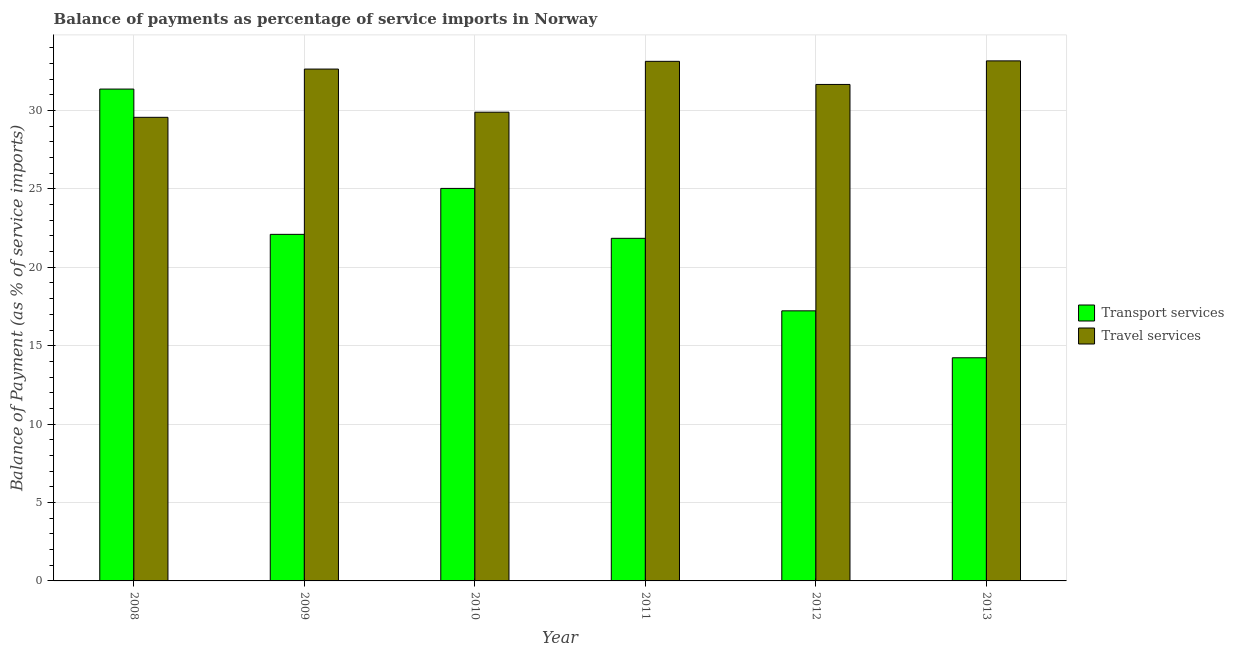Are the number of bars per tick equal to the number of legend labels?
Offer a terse response. Yes. Are the number of bars on each tick of the X-axis equal?
Your response must be concise. Yes. What is the label of the 1st group of bars from the left?
Keep it short and to the point. 2008. What is the balance of payments of travel services in 2012?
Make the answer very short. 31.66. Across all years, what is the maximum balance of payments of travel services?
Provide a short and direct response. 33.16. Across all years, what is the minimum balance of payments of transport services?
Offer a very short reply. 14.23. What is the total balance of payments of travel services in the graph?
Your response must be concise. 190.05. What is the difference between the balance of payments of transport services in 2011 and that in 2013?
Provide a short and direct response. 7.62. What is the difference between the balance of payments of travel services in 2012 and the balance of payments of transport services in 2008?
Your answer should be very brief. 2.1. What is the average balance of payments of travel services per year?
Your answer should be very brief. 31.67. What is the ratio of the balance of payments of transport services in 2012 to that in 2013?
Your response must be concise. 1.21. What is the difference between the highest and the second highest balance of payments of transport services?
Keep it short and to the point. 6.33. What is the difference between the highest and the lowest balance of payments of transport services?
Give a very brief answer. 17.13. In how many years, is the balance of payments of transport services greater than the average balance of payments of transport services taken over all years?
Provide a short and direct response. 3. What does the 1st bar from the left in 2011 represents?
Make the answer very short. Transport services. What does the 1st bar from the right in 2009 represents?
Your response must be concise. Travel services. How many bars are there?
Offer a terse response. 12. Are all the bars in the graph horizontal?
Your answer should be compact. No. Does the graph contain any zero values?
Provide a succinct answer. No. Does the graph contain grids?
Your answer should be compact. Yes. How many legend labels are there?
Your response must be concise. 2. How are the legend labels stacked?
Offer a very short reply. Vertical. What is the title of the graph?
Provide a short and direct response. Balance of payments as percentage of service imports in Norway. What is the label or title of the X-axis?
Ensure brevity in your answer.  Year. What is the label or title of the Y-axis?
Ensure brevity in your answer.  Balance of Payment (as % of service imports). What is the Balance of Payment (as % of service imports) of Transport services in 2008?
Ensure brevity in your answer.  31.36. What is the Balance of Payment (as % of service imports) of Travel services in 2008?
Give a very brief answer. 29.56. What is the Balance of Payment (as % of service imports) in Transport services in 2009?
Give a very brief answer. 22.1. What is the Balance of Payment (as % of service imports) of Travel services in 2009?
Provide a succinct answer. 32.64. What is the Balance of Payment (as % of service imports) in Transport services in 2010?
Offer a terse response. 25.03. What is the Balance of Payment (as % of service imports) in Travel services in 2010?
Provide a short and direct response. 29.89. What is the Balance of Payment (as % of service imports) in Transport services in 2011?
Provide a short and direct response. 21.85. What is the Balance of Payment (as % of service imports) of Travel services in 2011?
Ensure brevity in your answer.  33.13. What is the Balance of Payment (as % of service imports) of Transport services in 2012?
Your answer should be compact. 17.22. What is the Balance of Payment (as % of service imports) of Travel services in 2012?
Your response must be concise. 31.66. What is the Balance of Payment (as % of service imports) of Transport services in 2013?
Provide a short and direct response. 14.23. What is the Balance of Payment (as % of service imports) in Travel services in 2013?
Make the answer very short. 33.16. Across all years, what is the maximum Balance of Payment (as % of service imports) of Transport services?
Provide a short and direct response. 31.36. Across all years, what is the maximum Balance of Payment (as % of service imports) of Travel services?
Offer a very short reply. 33.16. Across all years, what is the minimum Balance of Payment (as % of service imports) of Transport services?
Offer a very short reply. 14.23. Across all years, what is the minimum Balance of Payment (as % of service imports) in Travel services?
Provide a short and direct response. 29.56. What is the total Balance of Payment (as % of service imports) in Transport services in the graph?
Make the answer very short. 131.79. What is the total Balance of Payment (as % of service imports) in Travel services in the graph?
Keep it short and to the point. 190.05. What is the difference between the Balance of Payment (as % of service imports) of Transport services in 2008 and that in 2009?
Ensure brevity in your answer.  9.26. What is the difference between the Balance of Payment (as % of service imports) in Travel services in 2008 and that in 2009?
Give a very brief answer. -3.08. What is the difference between the Balance of Payment (as % of service imports) in Transport services in 2008 and that in 2010?
Your answer should be compact. 6.33. What is the difference between the Balance of Payment (as % of service imports) of Travel services in 2008 and that in 2010?
Offer a terse response. -0.33. What is the difference between the Balance of Payment (as % of service imports) of Transport services in 2008 and that in 2011?
Your answer should be very brief. 9.52. What is the difference between the Balance of Payment (as % of service imports) of Travel services in 2008 and that in 2011?
Provide a succinct answer. -3.57. What is the difference between the Balance of Payment (as % of service imports) of Transport services in 2008 and that in 2012?
Give a very brief answer. 14.14. What is the difference between the Balance of Payment (as % of service imports) of Travel services in 2008 and that in 2012?
Make the answer very short. -2.1. What is the difference between the Balance of Payment (as % of service imports) of Transport services in 2008 and that in 2013?
Your answer should be compact. 17.13. What is the difference between the Balance of Payment (as % of service imports) in Travel services in 2008 and that in 2013?
Provide a succinct answer. -3.6. What is the difference between the Balance of Payment (as % of service imports) in Transport services in 2009 and that in 2010?
Your answer should be compact. -2.93. What is the difference between the Balance of Payment (as % of service imports) in Travel services in 2009 and that in 2010?
Your answer should be very brief. 2.75. What is the difference between the Balance of Payment (as % of service imports) of Transport services in 2009 and that in 2011?
Your response must be concise. 0.25. What is the difference between the Balance of Payment (as % of service imports) of Travel services in 2009 and that in 2011?
Make the answer very short. -0.49. What is the difference between the Balance of Payment (as % of service imports) in Transport services in 2009 and that in 2012?
Offer a terse response. 4.88. What is the difference between the Balance of Payment (as % of service imports) of Travel services in 2009 and that in 2012?
Your response must be concise. 0.98. What is the difference between the Balance of Payment (as % of service imports) of Transport services in 2009 and that in 2013?
Make the answer very short. 7.87. What is the difference between the Balance of Payment (as % of service imports) of Travel services in 2009 and that in 2013?
Your response must be concise. -0.52. What is the difference between the Balance of Payment (as % of service imports) of Transport services in 2010 and that in 2011?
Your answer should be very brief. 3.18. What is the difference between the Balance of Payment (as % of service imports) in Travel services in 2010 and that in 2011?
Ensure brevity in your answer.  -3.24. What is the difference between the Balance of Payment (as % of service imports) of Transport services in 2010 and that in 2012?
Keep it short and to the point. 7.81. What is the difference between the Balance of Payment (as % of service imports) in Travel services in 2010 and that in 2012?
Provide a short and direct response. -1.77. What is the difference between the Balance of Payment (as % of service imports) of Transport services in 2010 and that in 2013?
Keep it short and to the point. 10.8. What is the difference between the Balance of Payment (as % of service imports) of Travel services in 2010 and that in 2013?
Ensure brevity in your answer.  -3.27. What is the difference between the Balance of Payment (as % of service imports) of Transport services in 2011 and that in 2012?
Your answer should be very brief. 4.62. What is the difference between the Balance of Payment (as % of service imports) of Travel services in 2011 and that in 2012?
Make the answer very short. 1.47. What is the difference between the Balance of Payment (as % of service imports) in Transport services in 2011 and that in 2013?
Keep it short and to the point. 7.62. What is the difference between the Balance of Payment (as % of service imports) of Travel services in 2011 and that in 2013?
Offer a very short reply. -0.03. What is the difference between the Balance of Payment (as % of service imports) of Transport services in 2012 and that in 2013?
Provide a succinct answer. 2.99. What is the difference between the Balance of Payment (as % of service imports) in Travel services in 2012 and that in 2013?
Provide a succinct answer. -1.5. What is the difference between the Balance of Payment (as % of service imports) of Transport services in 2008 and the Balance of Payment (as % of service imports) of Travel services in 2009?
Keep it short and to the point. -1.28. What is the difference between the Balance of Payment (as % of service imports) in Transport services in 2008 and the Balance of Payment (as % of service imports) in Travel services in 2010?
Make the answer very short. 1.47. What is the difference between the Balance of Payment (as % of service imports) in Transport services in 2008 and the Balance of Payment (as % of service imports) in Travel services in 2011?
Provide a succinct answer. -1.77. What is the difference between the Balance of Payment (as % of service imports) of Transport services in 2008 and the Balance of Payment (as % of service imports) of Travel services in 2012?
Provide a succinct answer. -0.3. What is the difference between the Balance of Payment (as % of service imports) in Transport services in 2008 and the Balance of Payment (as % of service imports) in Travel services in 2013?
Ensure brevity in your answer.  -1.8. What is the difference between the Balance of Payment (as % of service imports) in Transport services in 2009 and the Balance of Payment (as % of service imports) in Travel services in 2010?
Make the answer very short. -7.79. What is the difference between the Balance of Payment (as % of service imports) in Transport services in 2009 and the Balance of Payment (as % of service imports) in Travel services in 2011?
Ensure brevity in your answer.  -11.03. What is the difference between the Balance of Payment (as % of service imports) of Transport services in 2009 and the Balance of Payment (as % of service imports) of Travel services in 2012?
Offer a very short reply. -9.56. What is the difference between the Balance of Payment (as % of service imports) in Transport services in 2009 and the Balance of Payment (as % of service imports) in Travel services in 2013?
Provide a short and direct response. -11.06. What is the difference between the Balance of Payment (as % of service imports) of Transport services in 2010 and the Balance of Payment (as % of service imports) of Travel services in 2011?
Provide a short and direct response. -8.1. What is the difference between the Balance of Payment (as % of service imports) of Transport services in 2010 and the Balance of Payment (as % of service imports) of Travel services in 2012?
Give a very brief answer. -6.63. What is the difference between the Balance of Payment (as % of service imports) in Transport services in 2010 and the Balance of Payment (as % of service imports) in Travel services in 2013?
Make the answer very short. -8.13. What is the difference between the Balance of Payment (as % of service imports) in Transport services in 2011 and the Balance of Payment (as % of service imports) in Travel services in 2012?
Your answer should be very brief. -9.81. What is the difference between the Balance of Payment (as % of service imports) in Transport services in 2011 and the Balance of Payment (as % of service imports) in Travel services in 2013?
Provide a succinct answer. -11.32. What is the difference between the Balance of Payment (as % of service imports) in Transport services in 2012 and the Balance of Payment (as % of service imports) in Travel services in 2013?
Provide a succinct answer. -15.94. What is the average Balance of Payment (as % of service imports) in Transport services per year?
Give a very brief answer. 21.97. What is the average Balance of Payment (as % of service imports) in Travel services per year?
Provide a short and direct response. 31.67. In the year 2008, what is the difference between the Balance of Payment (as % of service imports) of Transport services and Balance of Payment (as % of service imports) of Travel services?
Your response must be concise. 1.8. In the year 2009, what is the difference between the Balance of Payment (as % of service imports) in Transport services and Balance of Payment (as % of service imports) in Travel services?
Keep it short and to the point. -10.54. In the year 2010, what is the difference between the Balance of Payment (as % of service imports) in Transport services and Balance of Payment (as % of service imports) in Travel services?
Give a very brief answer. -4.86. In the year 2011, what is the difference between the Balance of Payment (as % of service imports) of Transport services and Balance of Payment (as % of service imports) of Travel services?
Give a very brief answer. -11.29. In the year 2012, what is the difference between the Balance of Payment (as % of service imports) in Transport services and Balance of Payment (as % of service imports) in Travel services?
Make the answer very short. -14.44. In the year 2013, what is the difference between the Balance of Payment (as % of service imports) of Transport services and Balance of Payment (as % of service imports) of Travel services?
Keep it short and to the point. -18.93. What is the ratio of the Balance of Payment (as % of service imports) of Transport services in 2008 to that in 2009?
Give a very brief answer. 1.42. What is the ratio of the Balance of Payment (as % of service imports) of Travel services in 2008 to that in 2009?
Your answer should be compact. 0.91. What is the ratio of the Balance of Payment (as % of service imports) in Transport services in 2008 to that in 2010?
Your answer should be very brief. 1.25. What is the ratio of the Balance of Payment (as % of service imports) in Transport services in 2008 to that in 2011?
Offer a very short reply. 1.44. What is the ratio of the Balance of Payment (as % of service imports) of Travel services in 2008 to that in 2011?
Your response must be concise. 0.89. What is the ratio of the Balance of Payment (as % of service imports) of Transport services in 2008 to that in 2012?
Keep it short and to the point. 1.82. What is the ratio of the Balance of Payment (as % of service imports) in Travel services in 2008 to that in 2012?
Your answer should be compact. 0.93. What is the ratio of the Balance of Payment (as % of service imports) in Transport services in 2008 to that in 2013?
Keep it short and to the point. 2.2. What is the ratio of the Balance of Payment (as % of service imports) in Travel services in 2008 to that in 2013?
Your response must be concise. 0.89. What is the ratio of the Balance of Payment (as % of service imports) of Transport services in 2009 to that in 2010?
Make the answer very short. 0.88. What is the ratio of the Balance of Payment (as % of service imports) of Travel services in 2009 to that in 2010?
Give a very brief answer. 1.09. What is the ratio of the Balance of Payment (as % of service imports) in Transport services in 2009 to that in 2011?
Give a very brief answer. 1.01. What is the ratio of the Balance of Payment (as % of service imports) in Travel services in 2009 to that in 2011?
Provide a short and direct response. 0.99. What is the ratio of the Balance of Payment (as % of service imports) of Transport services in 2009 to that in 2012?
Keep it short and to the point. 1.28. What is the ratio of the Balance of Payment (as % of service imports) of Travel services in 2009 to that in 2012?
Keep it short and to the point. 1.03. What is the ratio of the Balance of Payment (as % of service imports) in Transport services in 2009 to that in 2013?
Provide a succinct answer. 1.55. What is the ratio of the Balance of Payment (as % of service imports) in Travel services in 2009 to that in 2013?
Provide a succinct answer. 0.98. What is the ratio of the Balance of Payment (as % of service imports) in Transport services in 2010 to that in 2011?
Offer a terse response. 1.15. What is the ratio of the Balance of Payment (as % of service imports) in Travel services in 2010 to that in 2011?
Make the answer very short. 0.9. What is the ratio of the Balance of Payment (as % of service imports) of Transport services in 2010 to that in 2012?
Your answer should be compact. 1.45. What is the ratio of the Balance of Payment (as % of service imports) of Travel services in 2010 to that in 2012?
Offer a very short reply. 0.94. What is the ratio of the Balance of Payment (as % of service imports) in Transport services in 2010 to that in 2013?
Keep it short and to the point. 1.76. What is the ratio of the Balance of Payment (as % of service imports) of Travel services in 2010 to that in 2013?
Keep it short and to the point. 0.9. What is the ratio of the Balance of Payment (as % of service imports) in Transport services in 2011 to that in 2012?
Your answer should be very brief. 1.27. What is the ratio of the Balance of Payment (as % of service imports) of Travel services in 2011 to that in 2012?
Keep it short and to the point. 1.05. What is the ratio of the Balance of Payment (as % of service imports) in Transport services in 2011 to that in 2013?
Your response must be concise. 1.54. What is the ratio of the Balance of Payment (as % of service imports) in Transport services in 2012 to that in 2013?
Ensure brevity in your answer.  1.21. What is the ratio of the Balance of Payment (as % of service imports) of Travel services in 2012 to that in 2013?
Your answer should be compact. 0.95. What is the difference between the highest and the second highest Balance of Payment (as % of service imports) of Transport services?
Give a very brief answer. 6.33. What is the difference between the highest and the second highest Balance of Payment (as % of service imports) in Travel services?
Offer a terse response. 0.03. What is the difference between the highest and the lowest Balance of Payment (as % of service imports) of Transport services?
Provide a succinct answer. 17.13. What is the difference between the highest and the lowest Balance of Payment (as % of service imports) of Travel services?
Offer a very short reply. 3.6. 